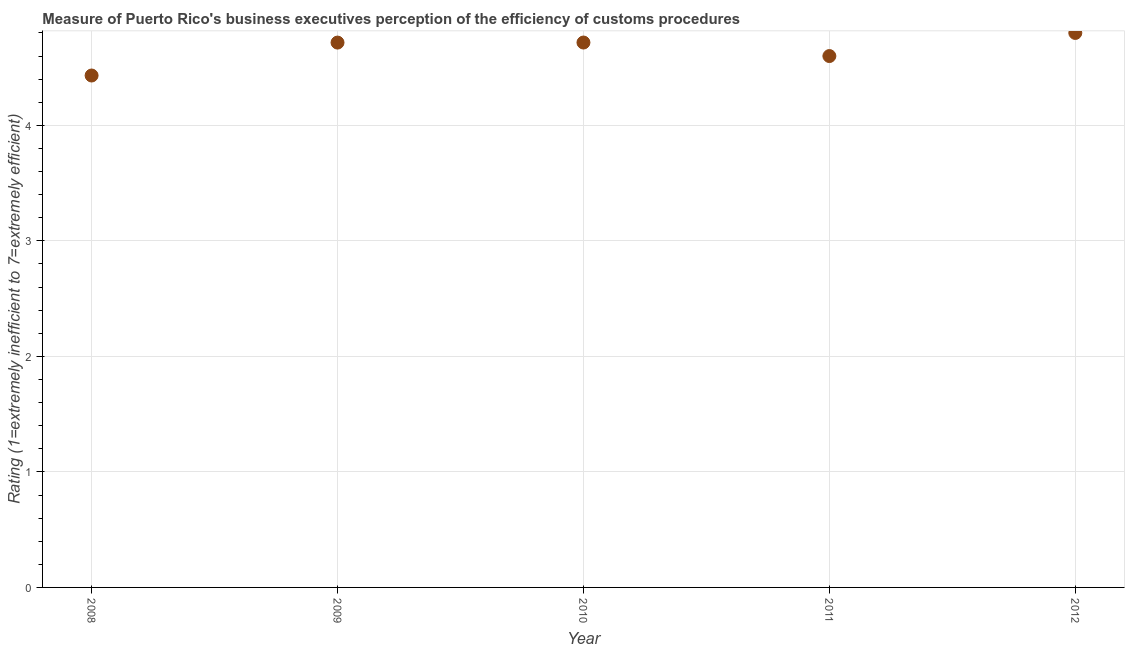What is the rating measuring burden of customs procedure in 2010?
Make the answer very short. 4.72. Across all years, what is the minimum rating measuring burden of customs procedure?
Make the answer very short. 4.43. In which year was the rating measuring burden of customs procedure maximum?
Keep it short and to the point. 2012. In which year was the rating measuring burden of customs procedure minimum?
Your answer should be very brief. 2008. What is the sum of the rating measuring burden of customs procedure?
Offer a very short reply. 23.27. What is the difference between the rating measuring burden of customs procedure in 2010 and 2012?
Provide a succinct answer. -0.08. What is the average rating measuring burden of customs procedure per year?
Offer a terse response. 4.65. What is the median rating measuring burden of customs procedure?
Your response must be concise. 4.72. Do a majority of the years between 2011 and 2012 (inclusive) have rating measuring burden of customs procedure greater than 1.4 ?
Your answer should be compact. Yes. What is the ratio of the rating measuring burden of customs procedure in 2008 to that in 2009?
Your answer should be very brief. 0.94. Is the rating measuring burden of customs procedure in 2009 less than that in 2011?
Your response must be concise. No. Is the difference between the rating measuring burden of customs procedure in 2011 and 2012 greater than the difference between any two years?
Your response must be concise. No. What is the difference between the highest and the second highest rating measuring burden of customs procedure?
Make the answer very short. 0.08. What is the difference between the highest and the lowest rating measuring burden of customs procedure?
Your response must be concise. 0.37. Does the rating measuring burden of customs procedure monotonically increase over the years?
Give a very brief answer. No. How many dotlines are there?
Offer a very short reply. 1. Are the values on the major ticks of Y-axis written in scientific E-notation?
Offer a very short reply. No. Does the graph contain any zero values?
Your response must be concise. No. Does the graph contain grids?
Keep it short and to the point. Yes. What is the title of the graph?
Your answer should be compact. Measure of Puerto Rico's business executives perception of the efficiency of customs procedures. What is the label or title of the X-axis?
Keep it short and to the point. Year. What is the label or title of the Y-axis?
Your answer should be very brief. Rating (1=extremely inefficient to 7=extremely efficient). What is the Rating (1=extremely inefficient to 7=extremely efficient) in 2008?
Your answer should be compact. 4.43. What is the Rating (1=extremely inefficient to 7=extremely efficient) in 2009?
Provide a short and direct response. 4.72. What is the Rating (1=extremely inefficient to 7=extremely efficient) in 2010?
Keep it short and to the point. 4.72. What is the Rating (1=extremely inefficient to 7=extremely efficient) in 2011?
Your answer should be very brief. 4.6. What is the difference between the Rating (1=extremely inefficient to 7=extremely efficient) in 2008 and 2009?
Offer a terse response. -0.29. What is the difference between the Rating (1=extremely inefficient to 7=extremely efficient) in 2008 and 2010?
Make the answer very short. -0.29. What is the difference between the Rating (1=extremely inefficient to 7=extremely efficient) in 2008 and 2011?
Ensure brevity in your answer.  -0.17. What is the difference between the Rating (1=extremely inefficient to 7=extremely efficient) in 2008 and 2012?
Provide a succinct answer. -0.37. What is the difference between the Rating (1=extremely inefficient to 7=extremely efficient) in 2009 and 2010?
Your answer should be compact. -0. What is the difference between the Rating (1=extremely inefficient to 7=extremely efficient) in 2009 and 2011?
Your response must be concise. 0.12. What is the difference between the Rating (1=extremely inefficient to 7=extremely efficient) in 2009 and 2012?
Your answer should be compact. -0.08. What is the difference between the Rating (1=extremely inefficient to 7=extremely efficient) in 2010 and 2011?
Offer a terse response. 0.12. What is the difference between the Rating (1=extremely inefficient to 7=extremely efficient) in 2010 and 2012?
Your response must be concise. -0.08. What is the ratio of the Rating (1=extremely inefficient to 7=extremely efficient) in 2008 to that in 2009?
Your response must be concise. 0.94. What is the ratio of the Rating (1=extremely inefficient to 7=extremely efficient) in 2008 to that in 2010?
Keep it short and to the point. 0.94. What is the ratio of the Rating (1=extremely inefficient to 7=extremely efficient) in 2008 to that in 2012?
Your answer should be very brief. 0.92. What is the ratio of the Rating (1=extremely inefficient to 7=extremely efficient) in 2009 to that in 2010?
Offer a very short reply. 1. What is the ratio of the Rating (1=extremely inefficient to 7=extremely efficient) in 2009 to that in 2012?
Give a very brief answer. 0.98. What is the ratio of the Rating (1=extremely inefficient to 7=extremely efficient) in 2011 to that in 2012?
Provide a succinct answer. 0.96. 